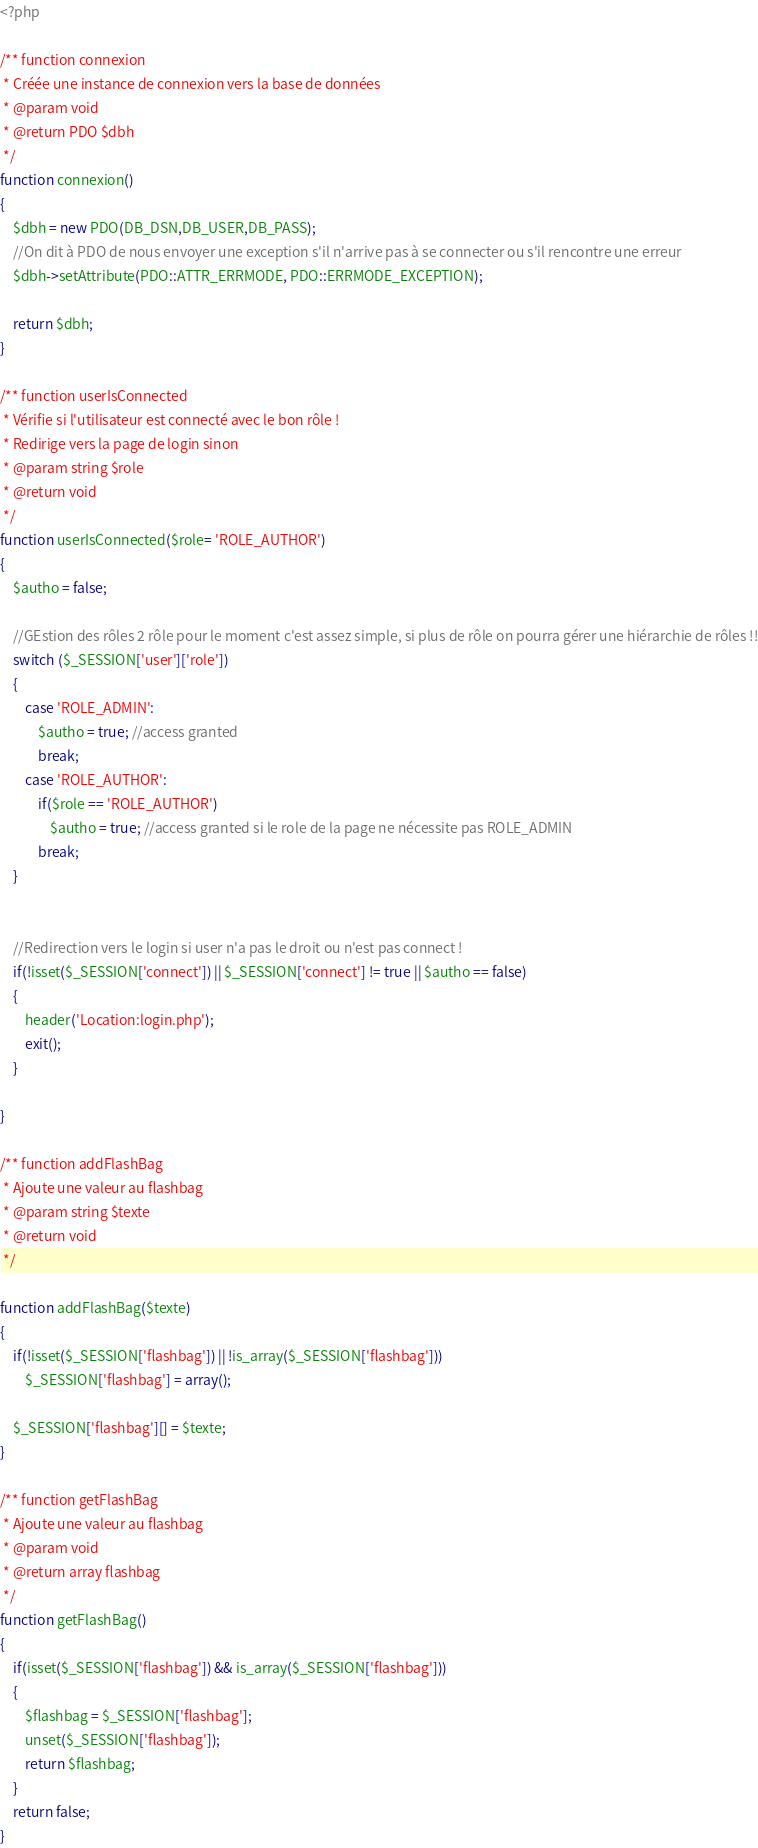<code> <loc_0><loc_0><loc_500><loc_500><_PHP_><?php

/** function connexion
 * Créée une instance de connexion vers la base de données
 * @param void
 * @return PDO $dbh
 */
function connexion()
{
    $dbh = new PDO(DB_DSN,DB_USER,DB_PASS);
    //On dit à PDO de nous envoyer une exception s'il n'arrive pas à se connecter ou s'il rencontre une erreur
    $dbh->setAttribute(PDO::ATTR_ERRMODE, PDO::ERRMODE_EXCEPTION);

    return $dbh;
}

/** function userIsConnected
 * Vérifie si l'utilisateur est connecté avec le bon rôle ! 
 * Redirige vers la page de login sinon 
 * @param string $role
 * @return void
 */
function userIsConnected($role= 'ROLE_AUTHOR')
{
    $autho = false;

    //GEstion des rôles 2 rôle pour le moment c'est assez simple, si plus de rôle on pourra gérer une hiérarchie de rôles !!
    switch ($_SESSION['user']['role'])
    {
        case 'ROLE_ADMIN':
            $autho = true; //access granted
            break;
        case 'ROLE_AUTHOR':
            if($role == 'ROLE_AUTHOR') 
                $autho = true; //access granted si le role de la page ne nécessite pas ROLE_ADMIN
            break;
    }


    //Redirection vers le login si user n'a pas le droit ou n'est pas connect !
    if(!isset($_SESSION['connect']) || $_SESSION['connect'] != true || $autho == false)
    {
        header('Location:login.php');
        exit();
    }
    
}

/** function addFlashBag
 * Ajoute une valeur au flashbag
 * @param string $texte
 * @return void
 */

function addFlashBag($texte)
{
    if(!isset($_SESSION['flashbag']) || !is_array($_SESSION['flashbag']))
        $_SESSION['flashbag'] = array();

    $_SESSION['flashbag'][] = $texte;
}

/** function getFlashBag
 * Ajoute une valeur au flashbag
 * @param void
 * @return array flashbag
 */
function getFlashBag()
{
    if(isset($_SESSION['flashbag']) && is_array($_SESSION['flashbag']))
    {
        $flashbag = $_SESSION['flashbag'];
        unset($_SESSION['flashbag']);
        return $flashbag;
    }
    return false;
}</code> 